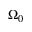<formula> <loc_0><loc_0><loc_500><loc_500>\Omega _ { 0 }</formula> 